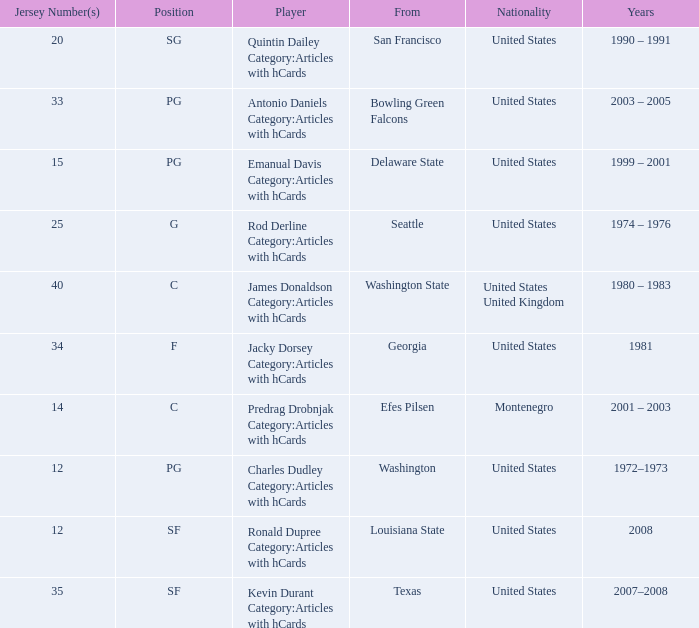What is the lowest jersey number of a player from louisiana state? 12.0. 